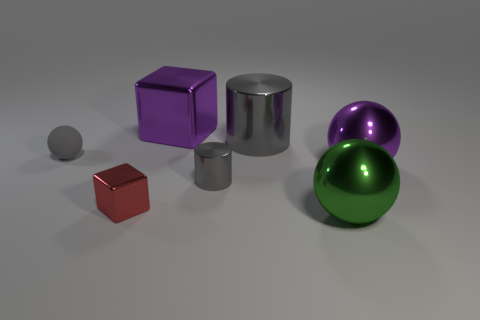Is there any other thing that has the same material as the gray ball?
Provide a short and direct response. No. The thing on the left side of the shiny block that is in front of the large purple object that is in front of the large purple cube is what shape?
Your response must be concise. Sphere. What number of other objects are there of the same shape as the gray rubber object?
Provide a succinct answer. 2. There is a tiny cylinder; is it the same color as the metal ball that is behind the small gray metal thing?
Ensure brevity in your answer.  No. How many purple metal objects are there?
Give a very brief answer. 2. How many objects are either big red rubber blocks or red blocks?
Offer a very short reply. 1. What size is the other cylinder that is the same color as the tiny metal cylinder?
Give a very brief answer. Large. There is a big green metallic sphere; are there any tiny red cubes on the left side of it?
Ensure brevity in your answer.  Yes. Is the number of large metal cubes that are on the right side of the red object greater than the number of small gray matte things that are on the left side of the big purple metallic sphere?
Give a very brief answer. No. The other object that is the same shape as the large gray object is what size?
Keep it short and to the point. Small. 